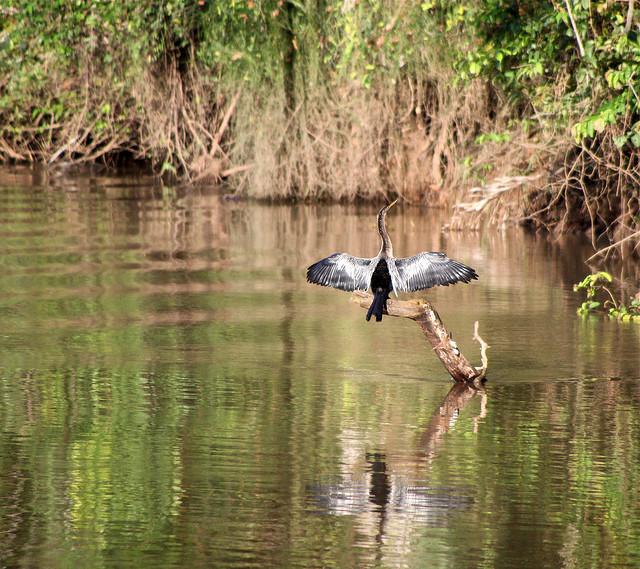Where was the picture taken of the bird?
Write a very short answer. Lake. Is the water calm?
Quick response, please. Yes. How many cranes?
Concise answer only. 1. 